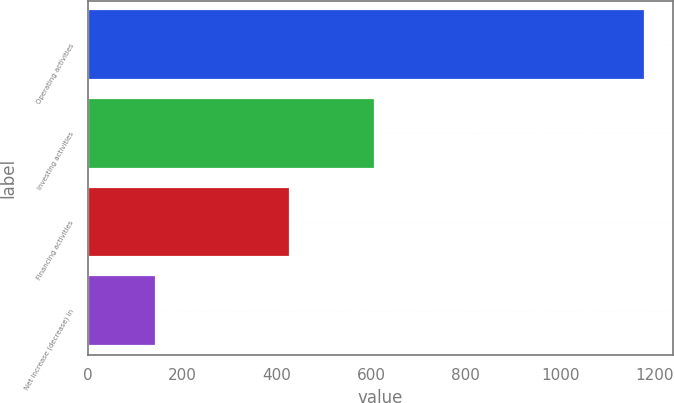Convert chart. <chart><loc_0><loc_0><loc_500><loc_500><bar_chart><fcel>Operating activities<fcel>Investing activities<fcel>Financing activities<fcel>Net increase (decrease) in<nl><fcel>1180.1<fcel>608.2<fcel>427.3<fcel>144.6<nl></chart> 